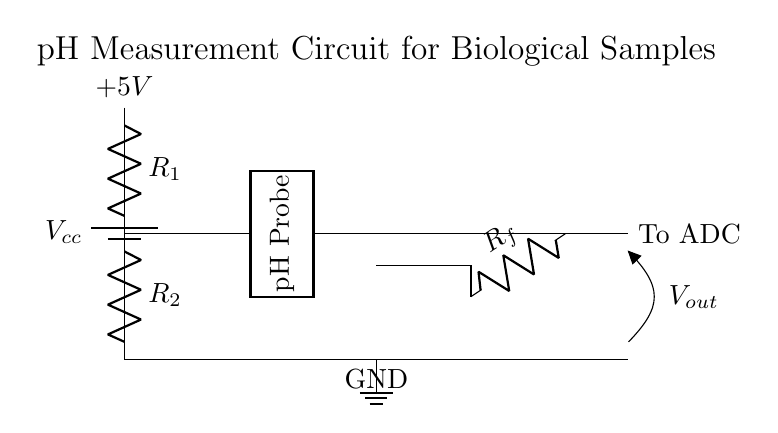What does R1 represent in this circuit? R1 is a resistor in the voltage divider network, labeled R1, which is used to help divide the voltage when measuring the pH.
Answer: R1 What is the output voltage when the pH probe produces a specific voltage? The output voltage is denoted as V out and is taken from the output of the operational amplifier, which processes the voltage from the divider.
Answer: V out What are the voltage levels in this circuit? The circuit shows a supply voltage of 5 volts from the battery, which is the potential difference used in the voltage divider.
Answer: 5V How many resistors are in the voltage divider? There are two resistors in the voltage divider, R1 and R2, which work together to create a divided voltage for measurement.
Answer: 2 What component amplifies the voltage after the voltage divider? The operational amplifier, labeled as op amp, amplifies the divided voltage to make it suitable for further measurement or processing.
Answer: Op amp What is the purpose of the pH probe in this circuit? The pH probe is used to detect the acidity or alkalinity of a biological sample, producing a voltage representative of its pH level for the divider circuit to process.
Answer: To measure pH What is the reference point for the voltage measurements in this circuit? The ground point, indicated in the circuit, acts as the reference point for all voltage measurements, ensuring they are taken relative to zero volts.
Answer: Ground 